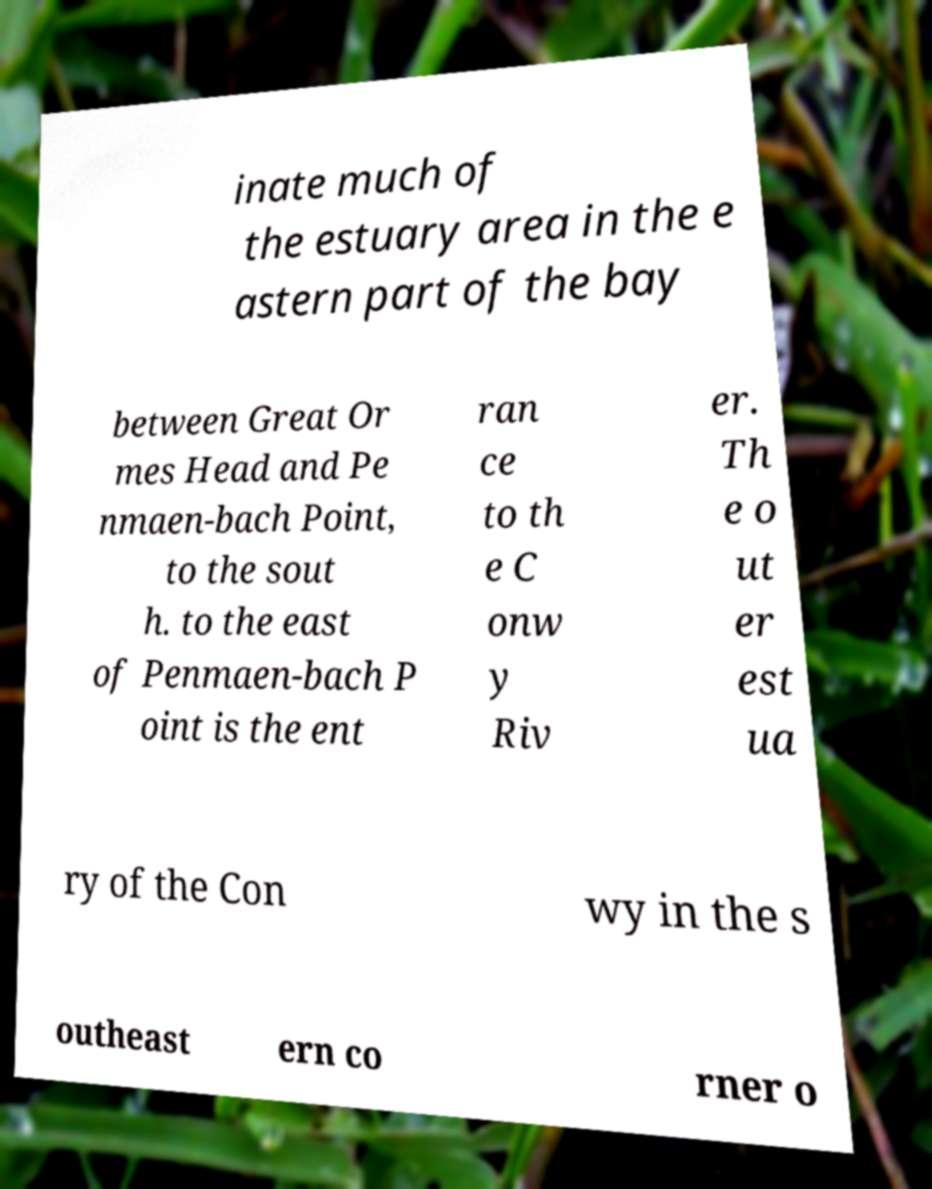Can you accurately transcribe the text from the provided image for me? inate much of the estuary area in the e astern part of the bay between Great Or mes Head and Pe nmaen-bach Point, to the sout h. to the east of Penmaen-bach P oint is the ent ran ce to th e C onw y Riv er. Th e o ut er est ua ry of the Con wy in the s outheast ern co rner o 